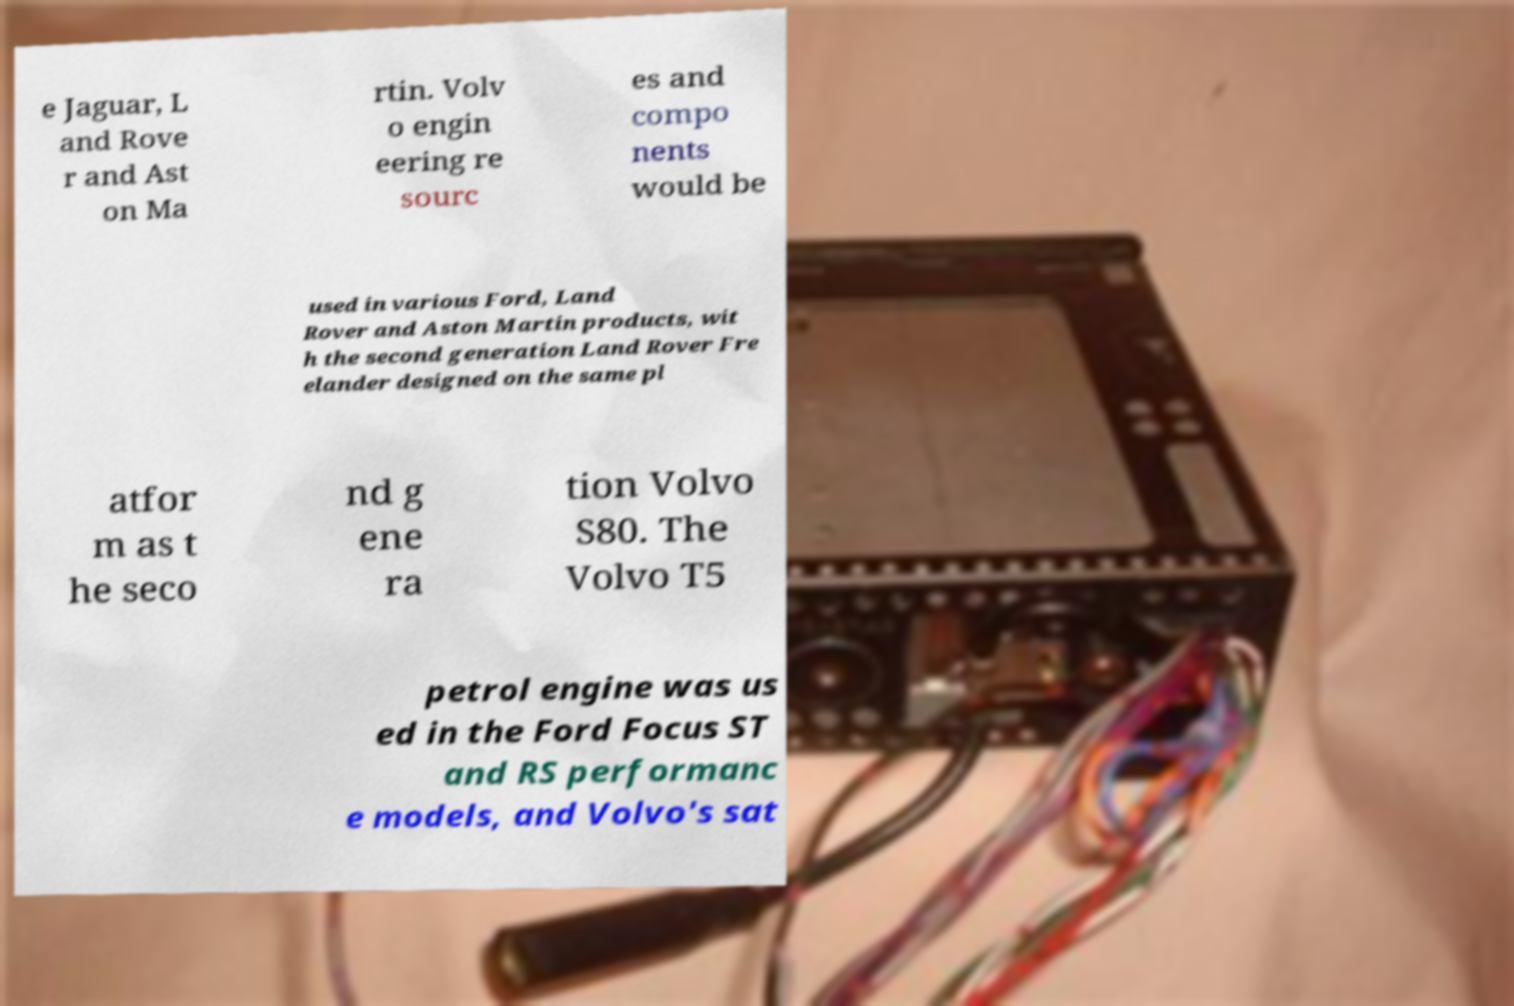Please read and relay the text visible in this image. What does it say? e Jaguar, L and Rove r and Ast on Ma rtin. Volv o engin eering re sourc es and compo nents would be used in various Ford, Land Rover and Aston Martin products, wit h the second generation Land Rover Fre elander designed on the same pl atfor m as t he seco nd g ene ra tion Volvo S80. The Volvo T5 petrol engine was us ed in the Ford Focus ST and RS performanc e models, and Volvo's sat 